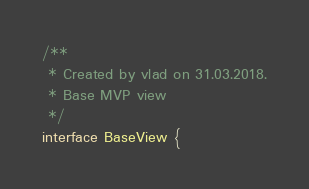<code> <loc_0><loc_0><loc_500><loc_500><_Kotlin_>/**
 * Created by vlad on 31.03.2018.
 * Base MVP view
 */
interface BaseView {</code> 